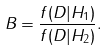<formula> <loc_0><loc_0><loc_500><loc_500>B = \frac { f ( D | H _ { 1 } ) } { f ( D | H _ { 2 } ) } .</formula> 